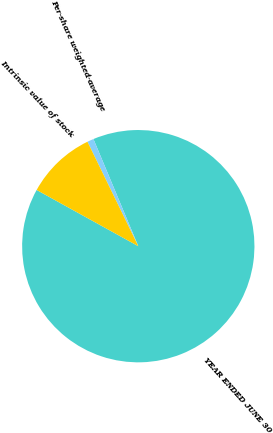Convert chart to OTSL. <chart><loc_0><loc_0><loc_500><loc_500><pie_chart><fcel>YEAR ENDED JUNE 30<fcel>Per-share weighted-average<fcel>Intrinsic value of stock<nl><fcel>89.35%<fcel>0.9%<fcel>9.75%<nl></chart> 